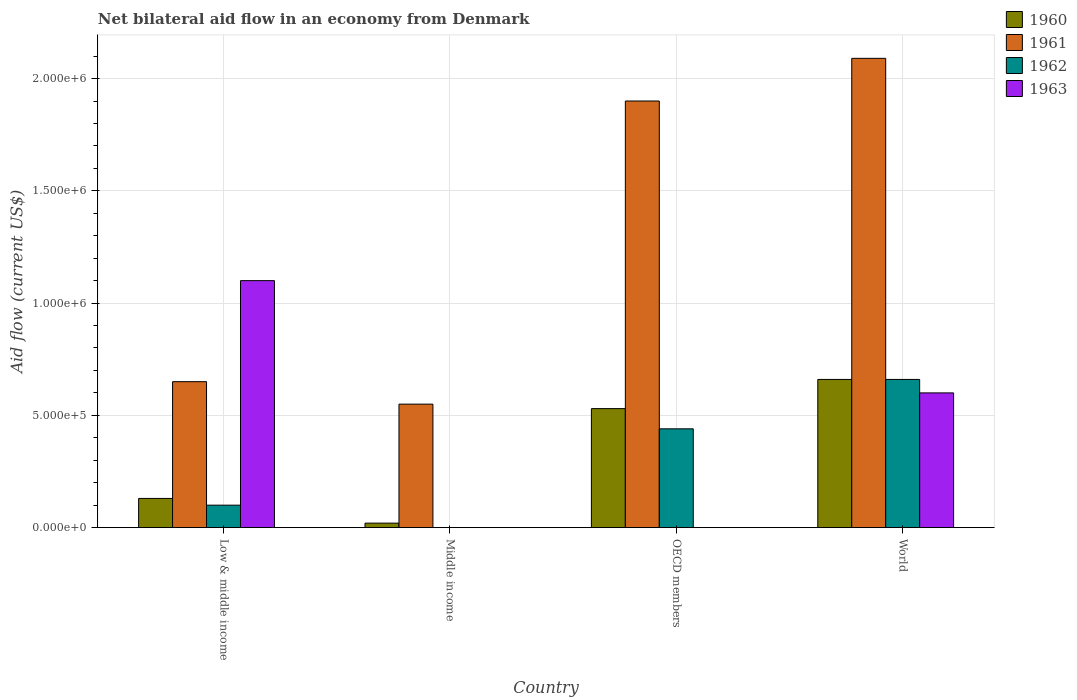How many different coloured bars are there?
Your answer should be very brief. 4. Are the number of bars on each tick of the X-axis equal?
Give a very brief answer. No. In how many cases, is the number of bars for a given country not equal to the number of legend labels?
Ensure brevity in your answer.  2. Across all countries, what is the minimum net bilateral aid flow in 1962?
Ensure brevity in your answer.  0. What is the total net bilateral aid flow in 1961 in the graph?
Offer a very short reply. 5.19e+06. What is the difference between the net bilateral aid flow in 1961 in OECD members and the net bilateral aid flow in 1962 in Middle income?
Keep it short and to the point. 1.90e+06. What is the ratio of the net bilateral aid flow in 1960 in Low & middle income to that in OECD members?
Provide a short and direct response. 0.25. What is the difference between the highest and the second highest net bilateral aid flow in 1961?
Give a very brief answer. 1.44e+06. What is the difference between the highest and the lowest net bilateral aid flow in 1963?
Your response must be concise. 1.10e+06. In how many countries, is the net bilateral aid flow in 1962 greater than the average net bilateral aid flow in 1962 taken over all countries?
Offer a terse response. 2. Is the sum of the net bilateral aid flow in 1962 in Low & middle income and World greater than the maximum net bilateral aid flow in 1961 across all countries?
Your answer should be compact. No. What is the difference between two consecutive major ticks on the Y-axis?
Your answer should be compact. 5.00e+05. Are the values on the major ticks of Y-axis written in scientific E-notation?
Your response must be concise. Yes. How many legend labels are there?
Make the answer very short. 4. How are the legend labels stacked?
Your answer should be very brief. Vertical. What is the title of the graph?
Keep it short and to the point. Net bilateral aid flow in an economy from Denmark. Does "1975" appear as one of the legend labels in the graph?
Ensure brevity in your answer.  No. What is the label or title of the Y-axis?
Give a very brief answer. Aid flow (current US$). What is the Aid flow (current US$) of 1960 in Low & middle income?
Ensure brevity in your answer.  1.30e+05. What is the Aid flow (current US$) in 1961 in Low & middle income?
Your answer should be compact. 6.50e+05. What is the Aid flow (current US$) in 1962 in Low & middle income?
Give a very brief answer. 1.00e+05. What is the Aid flow (current US$) of 1963 in Low & middle income?
Keep it short and to the point. 1.10e+06. What is the Aid flow (current US$) of 1960 in Middle income?
Make the answer very short. 2.00e+04. What is the Aid flow (current US$) in 1961 in Middle income?
Ensure brevity in your answer.  5.50e+05. What is the Aid flow (current US$) of 1960 in OECD members?
Keep it short and to the point. 5.30e+05. What is the Aid flow (current US$) of 1961 in OECD members?
Make the answer very short. 1.90e+06. What is the Aid flow (current US$) in 1962 in OECD members?
Give a very brief answer. 4.40e+05. What is the Aid flow (current US$) of 1960 in World?
Give a very brief answer. 6.60e+05. What is the Aid flow (current US$) of 1961 in World?
Your response must be concise. 2.09e+06. What is the Aid flow (current US$) in 1963 in World?
Ensure brevity in your answer.  6.00e+05. Across all countries, what is the maximum Aid flow (current US$) of 1960?
Give a very brief answer. 6.60e+05. Across all countries, what is the maximum Aid flow (current US$) in 1961?
Ensure brevity in your answer.  2.09e+06. Across all countries, what is the maximum Aid flow (current US$) in 1962?
Give a very brief answer. 6.60e+05. Across all countries, what is the maximum Aid flow (current US$) in 1963?
Your response must be concise. 1.10e+06. Across all countries, what is the minimum Aid flow (current US$) in 1960?
Give a very brief answer. 2.00e+04. Across all countries, what is the minimum Aid flow (current US$) of 1961?
Provide a succinct answer. 5.50e+05. Across all countries, what is the minimum Aid flow (current US$) of 1962?
Ensure brevity in your answer.  0. Across all countries, what is the minimum Aid flow (current US$) of 1963?
Your answer should be very brief. 0. What is the total Aid flow (current US$) in 1960 in the graph?
Your response must be concise. 1.34e+06. What is the total Aid flow (current US$) of 1961 in the graph?
Your answer should be compact. 5.19e+06. What is the total Aid flow (current US$) in 1962 in the graph?
Give a very brief answer. 1.20e+06. What is the total Aid flow (current US$) in 1963 in the graph?
Make the answer very short. 1.70e+06. What is the difference between the Aid flow (current US$) in 1960 in Low & middle income and that in Middle income?
Your answer should be compact. 1.10e+05. What is the difference between the Aid flow (current US$) of 1960 in Low & middle income and that in OECD members?
Your answer should be compact. -4.00e+05. What is the difference between the Aid flow (current US$) of 1961 in Low & middle income and that in OECD members?
Offer a terse response. -1.25e+06. What is the difference between the Aid flow (current US$) in 1960 in Low & middle income and that in World?
Offer a terse response. -5.30e+05. What is the difference between the Aid flow (current US$) of 1961 in Low & middle income and that in World?
Your answer should be compact. -1.44e+06. What is the difference between the Aid flow (current US$) in 1962 in Low & middle income and that in World?
Offer a terse response. -5.60e+05. What is the difference between the Aid flow (current US$) of 1963 in Low & middle income and that in World?
Provide a short and direct response. 5.00e+05. What is the difference between the Aid flow (current US$) of 1960 in Middle income and that in OECD members?
Make the answer very short. -5.10e+05. What is the difference between the Aid flow (current US$) of 1961 in Middle income and that in OECD members?
Your response must be concise. -1.35e+06. What is the difference between the Aid flow (current US$) in 1960 in Middle income and that in World?
Your response must be concise. -6.40e+05. What is the difference between the Aid flow (current US$) of 1961 in Middle income and that in World?
Keep it short and to the point. -1.54e+06. What is the difference between the Aid flow (current US$) in 1961 in OECD members and that in World?
Provide a succinct answer. -1.90e+05. What is the difference between the Aid flow (current US$) in 1960 in Low & middle income and the Aid flow (current US$) in 1961 in Middle income?
Your response must be concise. -4.20e+05. What is the difference between the Aid flow (current US$) of 1960 in Low & middle income and the Aid flow (current US$) of 1961 in OECD members?
Keep it short and to the point. -1.77e+06. What is the difference between the Aid flow (current US$) in 1960 in Low & middle income and the Aid flow (current US$) in 1962 in OECD members?
Ensure brevity in your answer.  -3.10e+05. What is the difference between the Aid flow (current US$) of 1961 in Low & middle income and the Aid flow (current US$) of 1962 in OECD members?
Your answer should be very brief. 2.10e+05. What is the difference between the Aid flow (current US$) of 1960 in Low & middle income and the Aid flow (current US$) of 1961 in World?
Make the answer very short. -1.96e+06. What is the difference between the Aid flow (current US$) of 1960 in Low & middle income and the Aid flow (current US$) of 1962 in World?
Your answer should be very brief. -5.30e+05. What is the difference between the Aid flow (current US$) in 1960 in Low & middle income and the Aid flow (current US$) in 1963 in World?
Your response must be concise. -4.70e+05. What is the difference between the Aid flow (current US$) of 1961 in Low & middle income and the Aid flow (current US$) of 1962 in World?
Provide a succinct answer. -10000. What is the difference between the Aid flow (current US$) in 1961 in Low & middle income and the Aid flow (current US$) in 1963 in World?
Ensure brevity in your answer.  5.00e+04. What is the difference between the Aid flow (current US$) in 1962 in Low & middle income and the Aid flow (current US$) in 1963 in World?
Give a very brief answer. -5.00e+05. What is the difference between the Aid flow (current US$) in 1960 in Middle income and the Aid flow (current US$) in 1961 in OECD members?
Give a very brief answer. -1.88e+06. What is the difference between the Aid flow (current US$) of 1960 in Middle income and the Aid flow (current US$) of 1962 in OECD members?
Offer a terse response. -4.20e+05. What is the difference between the Aid flow (current US$) of 1961 in Middle income and the Aid flow (current US$) of 1962 in OECD members?
Give a very brief answer. 1.10e+05. What is the difference between the Aid flow (current US$) of 1960 in Middle income and the Aid flow (current US$) of 1961 in World?
Ensure brevity in your answer.  -2.07e+06. What is the difference between the Aid flow (current US$) in 1960 in Middle income and the Aid flow (current US$) in 1962 in World?
Give a very brief answer. -6.40e+05. What is the difference between the Aid flow (current US$) in 1960 in Middle income and the Aid flow (current US$) in 1963 in World?
Your response must be concise. -5.80e+05. What is the difference between the Aid flow (current US$) in 1961 in Middle income and the Aid flow (current US$) in 1963 in World?
Give a very brief answer. -5.00e+04. What is the difference between the Aid flow (current US$) of 1960 in OECD members and the Aid flow (current US$) of 1961 in World?
Make the answer very short. -1.56e+06. What is the difference between the Aid flow (current US$) in 1961 in OECD members and the Aid flow (current US$) in 1962 in World?
Ensure brevity in your answer.  1.24e+06. What is the difference between the Aid flow (current US$) of 1961 in OECD members and the Aid flow (current US$) of 1963 in World?
Offer a very short reply. 1.30e+06. What is the difference between the Aid flow (current US$) of 1962 in OECD members and the Aid flow (current US$) of 1963 in World?
Provide a short and direct response. -1.60e+05. What is the average Aid flow (current US$) in 1960 per country?
Give a very brief answer. 3.35e+05. What is the average Aid flow (current US$) of 1961 per country?
Offer a terse response. 1.30e+06. What is the average Aid flow (current US$) in 1962 per country?
Provide a succinct answer. 3.00e+05. What is the average Aid flow (current US$) of 1963 per country?
Offer a terse response. 4.25e+05. What is the difference between the Aid flow (current US$) in 1960 and Aid flow (current US$) in 1961 in Low & middle income?
Your response must be concise. -5.20e+05. What is the difference between the Aid flow (current US$) of 1960 and Aid flow (current US$) of 1962 in Low & middle income?
Your response must be concise. 3.00e+04. What is the difference between the Aid flow (current US$) in 1960 and Aid flow (current US$) in 1963 in Low & middle income?
Keep it short and to the point. -9.70e+05. What is the difference between the Aid flow (current US$) in 1961 and Aid flow (current US$) in 1963 in Low & middle income?
Your answer should be compact. -4.50e+05. What is the difference between the Aid flow (current US$) of 1960 and Aid flow (current US$) of 1961 in Middle income?
Offer a terse response. -5.30e+05. What is the difference between the Aid flow (current US$) of 1960 and Aid flow (current US$) of 1961 in OECD members?
Offer a very short reply. -1.37e+06. What is the difference between the Aid flow (current US$) in 1960 and Aid flow (current US$) in 1962 in OECD members?
Ensure brevity in your answer.  9.00e+04. What is the difference between the Aid flow (current US$) in 1961 and Aid flow (current US$) in 1962 in OECD members?
Ensure brevity in your answer.  1.46e+06. What is the difference between the Aid flow (current US$) of 1960 and Aid flow (current US$) of 1961 in World?
Offer a very short reply. -1.43e+06. What is the difference between the Aid flow (current US$) of 1960 and Aid flow (current US$) of 1962 in World?
Offer a very short reply. 0. What is the difference between the Aid flow (current US$) of 1960 and Aid flow (current US$) of 1963 in World?
Provide a succinct answer. 6.00e+04. What is the difference between the Aid flow (current US$) in 1961 and Aid flow (current US$) in 1962 in World?
Offer a very short reply. 1.43e+06. What is the difference between the Aid flow (current US$) in 1961 and Aid flow (current US$) in 1963 in World?
Keep it short and to the point. 1.49e+06. What is the ratio of the Aid flow (current US$) in 1961 in Low & middle income to that in Middle income?
Make the answer very short. 1.18. What is the ratio of the Aid flow (current US$) of 1960 in Low & middle income to that in OECD members?
Your response must be concise. 0.25. What is the ratio of the Aid flow (current US$) of 1961 in Low & middle income to that in OECD members?
Your answer should be compact. 0.34. What is the ratio of the Aid flow (current US$) of 1962 in Low & middle income to that in OECD members?
Give a very brief answer. 0.23. What is the ratio of the Aid flow (current US$) of 1960 in Low & middle income to that in World?
Your answer should be compact. 0.2. What is the ratio of the Aid flow (current US$) in 1961 in Low & middle income to that in World?
Your response must be concise. 0.31. What is the ratio of the Aid flow (current US$) in 1962 in Low & middle income to that in World?
Provide a short and direct response. 0.15. What is the ratio of the Aid flow (current US$) in 1963 in Low & middle income to that in World?
Provide a succinct answer. 1.83. What is the ratio of the Aid flow (current US$) in 1960 in Middle income to that in OECD members?
Offer a very short reply. 0.04. What is the ratio of the Aid flow (current US$) in 1961 in Middle income to that in OECD members?
Your answer should be compact. 0.29. What is the ratio of the Aid flow (current US$) of 1960 in Middle income to that in World?
Offer a very short reply. 0.03. What is the ratio of the Aid flow (current US$) in 1961 in Middle income to that in World?
Ensure brevity in your answer.  0.26. What is the ratio of the Aid flow (current US$) of 1960 in OECD members to that in World?
Make the answer very short. 0.8. What is the difference between the highest and the second highest Aid flow (current US$) of 1960?
Your response must be concise. 1.30e+05. What is the difference between the highest and the second highest Aid flow (current US$) in 1962?
Give a very brief answer. 2.20e+05. What is the difference between the highest and the lowest Aid flow (current US$) in 1960?
Give a very brief answer. 6.40e+05. What is the difference between the highest and the lowest Aid flow (current US$) of 1961?
Provide a succinct answer. 1.54e+06. What is the difference between the highest and the lowest Aid flow (current US$) in 1963?
Your answer should be very brief. 1.10e+06. 